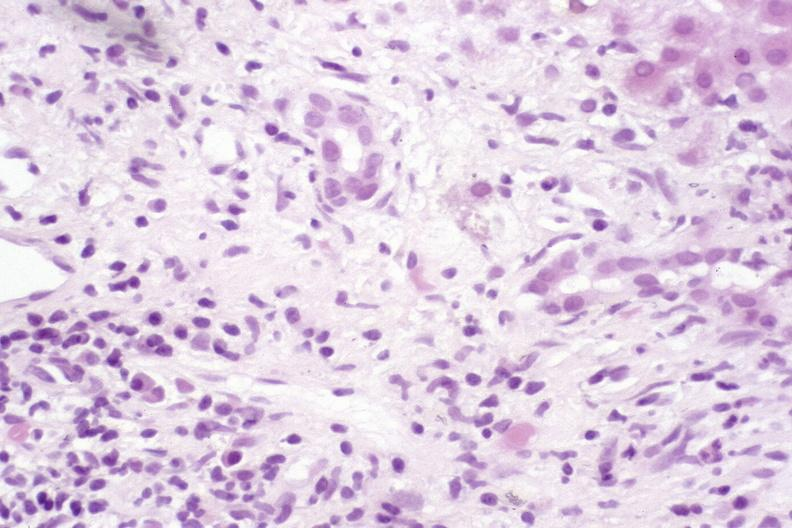does this image show primary sclerosing cholangitis?
Answer the question using a single word or phrase. Yes 